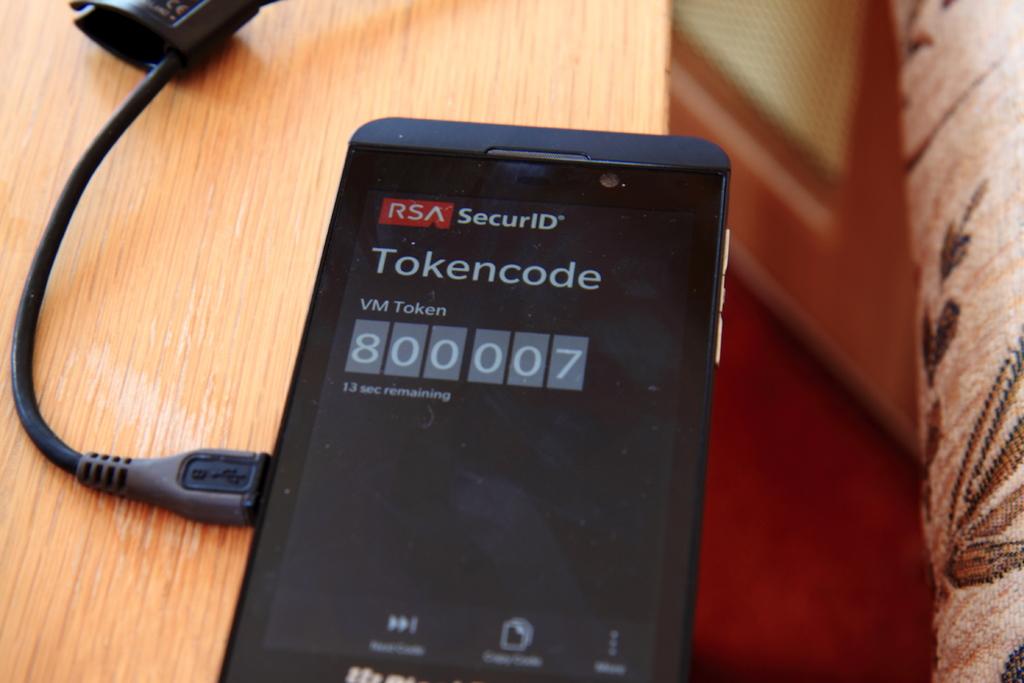What is the code displayed?
Make the answer very short. 800007. What is the type of code?
Your answer should be very brief. Tokencode. 